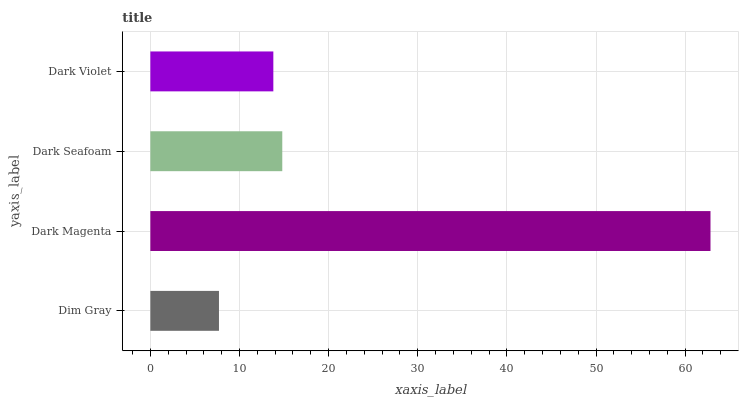Is Dim Gray the minimum?
Answer yes or no. Yes. Is Dark Magenta the maximum?
Answer yes or no. Yes. Is Dark Seafoam the minimum?
Answer yes or no. No. Is Dark Seafoam the maximum?
Answer yes or no. No. Is Dark Magenta greater than Dark Seafoam?
Answer yes or no. Yes. Is Dark Seafoam less than Dark Magenta?
Answer yes or no. Yes. Is Dark Seafoam greater than Dark Magenta?
Answer yes or no. No. Is Dark Magenta less than Dark Seafoam?
Answer yes or no. No. Is Dark Seafoam the high median?
Answer yes or no. Yes. Is Dark Violet the low median?
Answer yes or no. Yes. Is Dark Magenta the high median?
Answer yes or no. No. Is Dark Magenta the low median?
Answer yes or no. No. 